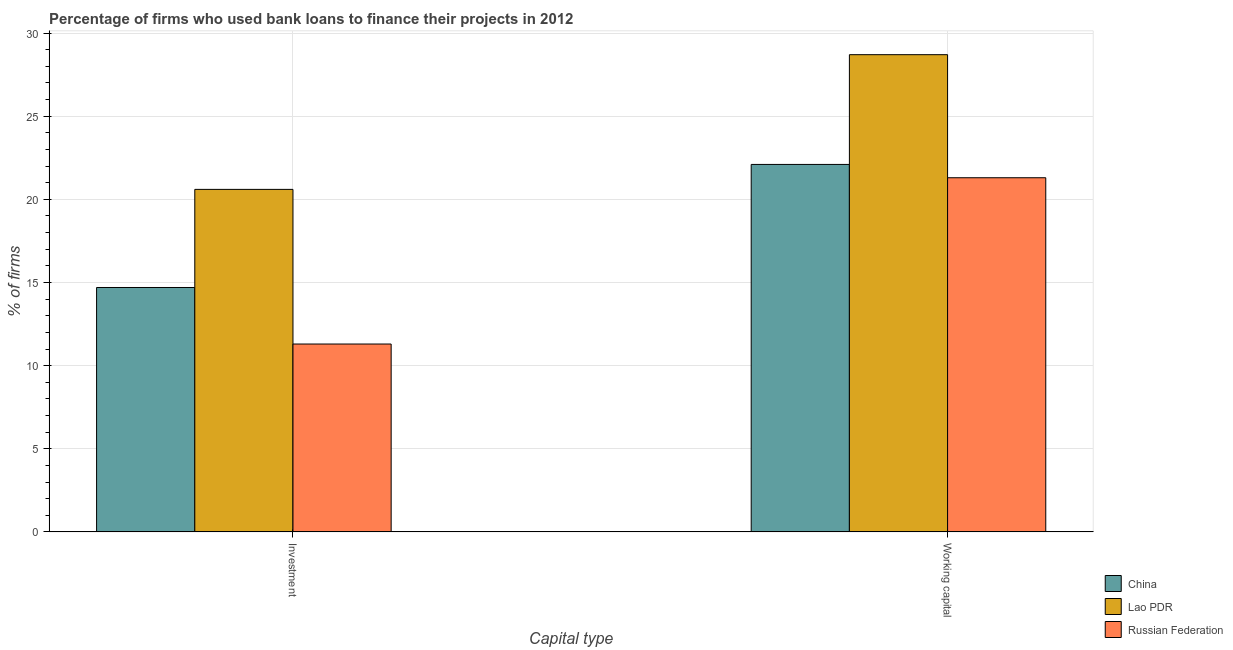How many different coloured bars are there?
Your response must be concise. 3. Are the number of bars on each tick of the X-axis equal?
Give a very brief answer. Yes. How many bars are there on the 1st tick from the left?
Give a very brief answer. 3. How many bars are there on the 2nd tick from the right?
Your response must be concise. 3. What is the label of the 2nd group of bars from the left?
Provide a succinct answer. Working capital. What is the percentage of firms using banks to finance investment in Lao PDR?
Give a very brief answer. 20.6. Across all countries, what is the maximum percentage of firms using banks to finance working capital?
Your response must be concise. 28.7. Across all countries, what is the minimum percentage of firms using banks to finance working capital?
Your response must be concise. 21.3. In which country was the percentage of firms using banks to finance working capital maximum?
Offer a very short reply. Lao PDR. In which country was the percentage of firms using banks to finance investment minimum?
Your answer should be compact. Russian Federation. What is the total percentage of firms using banks to finance investment in the graph?
Keep it short and to the point. 46.6. What is the difference between the percentage of firms using banks to finance investment in Lao PDR and that in Russian Federation?
Your answer should be very brief. 9.3. What is the difference between the percentage of firms using banks to finance investment in Russian Federation and the percentage of firms using banks to finance working capital in China?
Provide a short and direct response. -10.8. What is the average percentage of firms using banks to finance investment per country?
Keep it short and to the point. 15.53. What is the difference between the percentage of firms using banks to finance working capital and percentage of firms using banks to finance investment in China?
Offer a very short reply. 7.4. In how many countries, is the percentage of firms using banks to finance working capital greater than 17 %?
Keep it short and to the point. 3. What is the ratio of the percentage of firms using banks to finance investment in China to that in Lao PDR?
Provide a succinct answer. 0.71. Is the percentage of firms using banks to finance investment in Russian Federation less than that in China?
Provide a succinct answer. Yes. What does the 2nd bar from the left in Working capital represents?
Your answer should be compact. Lao PDR. What does the 1st bar from the right in Investment represents?
Provide a succinct answer. Russian Federation. Where does the legend appear in the graph?
Ensure brevity in your answer.  Bottom right. How many legend labels are there?
Keep it short and to the point. 3. How are the legend labels stacked?
Keep it short and to the point. Vertical. What is the title of the graph?
Offer a terse response. Percentage of firms who used bank loans to finance their projects in 2012. Does "Japan" appear as one of the legend labels in the graph?
Offer a very short reply. No. What is the label or title of the X-axis?
Your response must be concise. Capital type. What is the label or title of the Y-axis?
Offer a terse response. % of firms. What is the % of firms in Lao PDR in Investment?
Your answer should be very brief. 20.6. What is the % of firms of Russian Federation in Investment?
Your answer should be compact. 11.3. What is the % of firms of China in Working capital?
Provide a succinct answer. 22.1. What is the % of firms of Lao PDR in Working capital?
Make the answer very short. 28.7. What is the % of firms in Russian Federation in Working capital?
Provide a short and direct response. 21.3. Across all Capital type, what is the maximum % of firms of China?
Your answer should be compact. 22.1. Across all Capital type, what is the maximum % of firms in Lao PDR?
Make the answer very short. 28.7. Across all Capital type, what is the maximum % of firms of Russian Federation?
Provide a short and direct response. 21.3. Across all Capital type, what is the minimum % of firms in China?
Your answer should be very brief. 14.7. Across all Capital type, what is the minimum % of firms of Lao PDR?
Provide a short and direct response. 20.6. What is the total % of firms in China in the graph?
Make the answer very short. 36.8. What is the total % of firms of Lao PDR in the graph?
Your answer should be compact. 49.3. What is the total % of firms in Russian Federation in the graph?
Provide a succinct answer. 32.6. What is the difference between the % of firms of China in Investment and that in Working capital?
Offer a terse response. -7.4. What is the difference between the % of firms in Russian Federation in Investment and that in Working capital?
Keep it short and to the point. -10. What is the difference between the % of firms in China in Investment and the % of firms in Lao PDR in Working capital?
Keep it short and to the point. -14. What is the difference between the % of firms of China in Investment and the % of firms of Russian Federation in Working capital?
Your response must be concise. -6.6. What is the average % of firms in China per Capital type?
Keep it short and to the point. 18.4. What is the average % of firms of Lao PDR per Capital type?
Offer a very short reply. 24.65. What is the difference between the % of firms in China and % of firms in Lao PDR in Investment?
Provide a succinct answer. -5.9. What is the difference between the % of firms of Lao PDR and % of firms of Russian Federation in Investment?
Offer a terse response. 9.3. What is the difference between the % of firms of China and % of firms of Russian Federation in Working capital?
Offer a terse response. 0.8. What is the difference between the % of firms in Lao PDR and % of firms in Russian Federation in Working capital?
Your answer should be compact. 7.4. What is the ratio of the % of firms of China in Investment to that in Working capital?
Your answer should be very brief. 0.67. What is the ratio of the % of firms in Lao PDR in Investment to that in Working capital?
Offer a very short reply. 0.72. What is the ratio of the % of firms in Russian Federation in Investment to that in Working capital?
Your answer should be compact. 0.53. What is the difference between the highest and the second highest % of firms of Russian Federation?
Ensure brevity in your answer.  10. What is the difference between the highest and the lowest % of firms of Lao PDR?
Give a very brief answer. 8.1. 